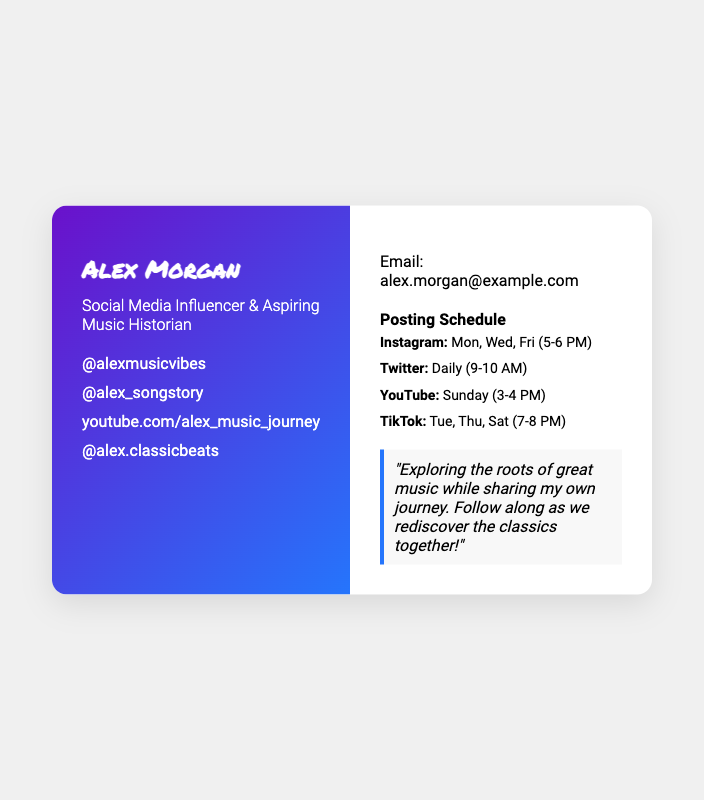What is Alex Morgan's profession? The document states that Alex Morgan is a "Social Media Influencer & Aspiring Music Historian."
Answer: Social Media Influencer & Aspiring Music Historian What is Alex's Instagram handle? The document includes links to social media which shows Alex's Instagram handle as "@alexmusicvibes."
Answer: @alexmusicvibes How often does Alex post on Twitter? The posting schedule mentions that Twitter posts are made daily, specifically "9-10 AM."
Answer: Daily What day does Alex post on YouTube? The schedule indicates that YouTube posts are made on Sundays.
Answer: Sunday What are the posting times for TikTok? The schedule states TikTok is posted on Tue, Thu, Sat between "7-8 PM."
Answer: Tue, Thu, Sat (7-8 PM) Why does Alex mention rediscovering classics? The document explains Alex's goal is to explore "the roots of great music while sharing my own journey".
Answer: Explore the roots of great music What type of card is this document presenting? This document presents a business card, which is indicated by its layout and information provided.
Answer: Business card What is Alex Morgan's email address? The document specifies an email address for Alex as "alex.morgan@example.com."
Answer: alex.morgan@example.com What is featured in the left side of the business card? The left side displays Alex's name, title, and social media handles.
Answer: Name, title, social media handles 